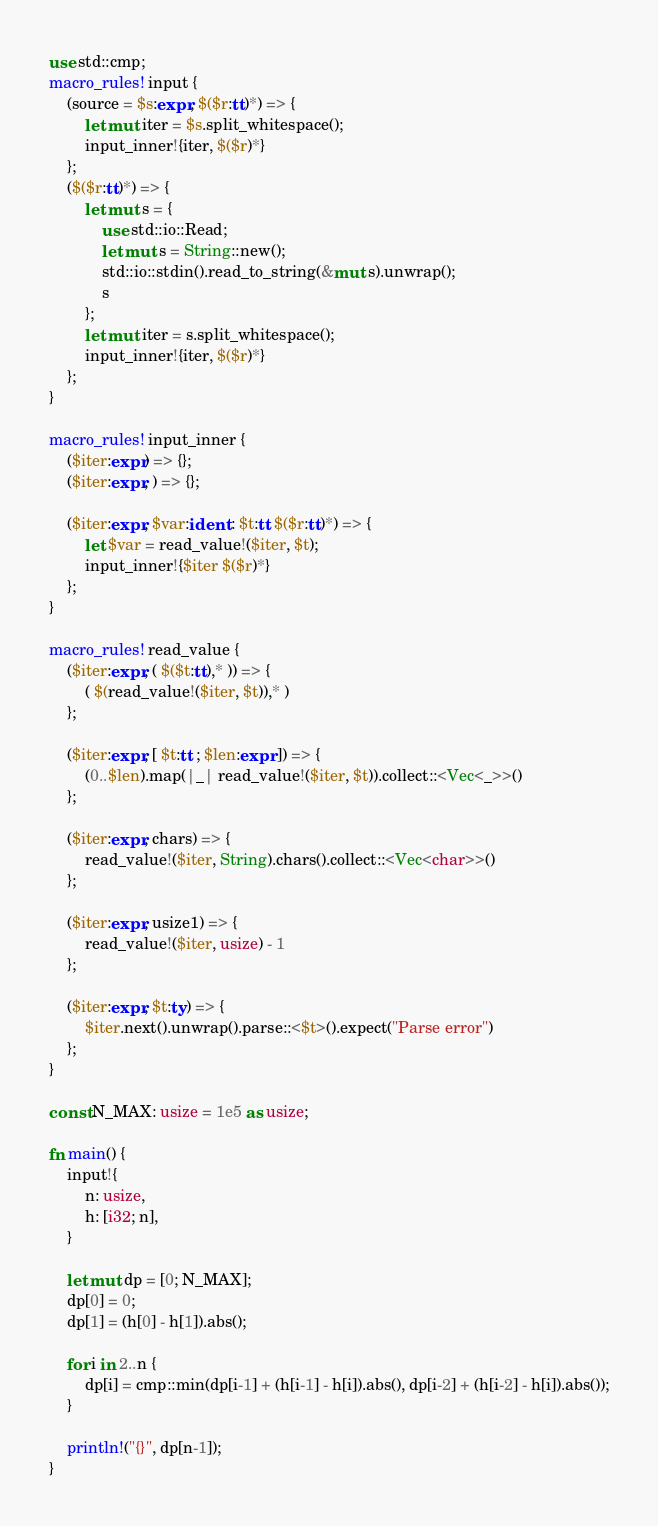<code> <loc_0><loc_0><loc_500><loc_500><_Rust_>use std::cmp;
macro_rules! input {
    (source = $s:expr, $($r:tt)*) => {
        let mut iter = $s.split_whitespace();
        input_inner!{iter, $($r)*}
    };
    ($($r:tt)*) => {
        let mut s = {
            use std::io::Read;
            let mut s = String::new();
            std::io::stdin().read_to_string(&mut s).unwrap();
            s
        };
        let mut iter = s.split_whitespace();
        input_inner!{iter, $($r)*}
    };
}

macro_rules! input_inner {
    ($iter:expr) => {};
    ($iter:expr, ) => {};

    ($iter:expr, $var:ident : $t:tt $($r:tt)*) => {
        let $var = read_value!($iter, $t);
        input_inner!{$iter $($r)*}
    };
}

macro_rules! read_value {
    ($iter:expr, ( $($t:tt),* )) => {
        ( $(read_value!($iter, $t)),* )
    };

    ($iter:expr, [ $t:tt ; $len:expr ]) => {
        (0..$len).map(|_| read_value!($iter, $t)).collect::<Vec<_>>()
    };

    ($iter:expr, chars) => {
        read_value!($iter, String).chars().collect::<Vec<char>>()
    };

    ($iter:expr, usize1) => {
        read_value!($iter, usize) - 1
    };

    ($iter:expr, $t:ty) => {
        $iter.next().unwrap().parse::<$t>().expect("Parse error")
    };
}

const N_MAX: usize = 1e5 as usize;

fn main() {
    input!{
        n: usize,
        h: [i32; n],
    }

    let mut dp = [0; N_MAX];
    dp[0] = 0;
    dp[1] = (h[0] - h[1]).abs();

    for i in 2..n {
        dp[i] = cmp::min(dp[i-1] + (h[i-1] - h[i]).abs(), dp[i-2] + (h[i-2] - h[i]).abs());
    }

    println!("{}", dp[n-1]);
}
</code> 